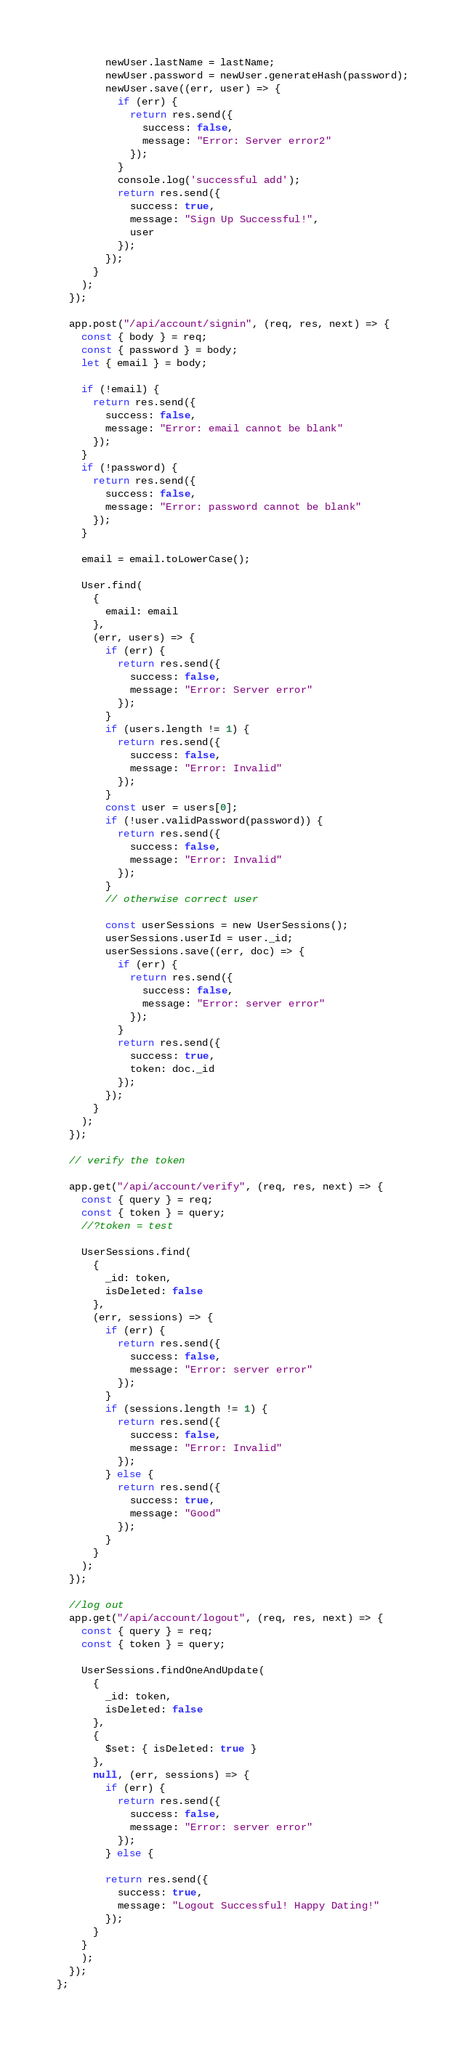<code> <loc_0><loc_0><loc_500><loc_500><_JavaScript_>        newUser.lastName = lastName;
        newUser.password = newUser.generateHash(password);
        newUser.save((err, user) => {
          if (err) {
            return res.send({
              success: false,
              message: "Error: Server error2"
            });
          }
          console.log('successful add');
          return res.send({
            success: true,
            message: "Sign Up Successful!",
            user
          });
        });
      }
    );
  });

  app.post("/api/account/signin", (req, res, next) => {
    const { body } = req;
    const { password } = body;
    let { email } = body;

    if (!email) {
      return res.send({
        success: false,
        message: "Error: email cannot be blank"
      });
    }
    if (!password) {
      return res.send({
        success: false,
        message: "Error: password cannot be blank"
      });
    }

    email = email.toLowerCase();

    User.find(
      {
        email: email
      },
      (err, users) => {
        if (err) {
          return res.send({
            success: false,
            message: "Error: Server error"
          });
        }
        if (users.length != 1) {
          return res.send({
            success: false,
            message: "Error: Invalid"
          });
        }
        const user = users[0];
        if (!user.validPassword(password)) {
          return res.send({
            success: false,
            message: "Error: Invalid"
          });
        }
        // otherwise correct user

        const userSessions = new UserSessions();
        userSessions.userId = user._id;
        userSessions.save((err, doc) => {
          if (err) {
            return res.send({
              success: false,
              message: "Error: server error"
            });
          }
          return res.send({
            success: true,
            token: doc._id
          });
        });
      }
    );
  });

  // verify the token

  app.get("/api/account/verify", (req, res, next) => {
    const { query } = req;
    const { token } = query;
    //?token = test

    UserSessions.find(
      {
        _id: token,
        isDeleted: false
      },
      (err, sessions) => {
        if (err) {
          return res.send({
            success: false,
            message: "Error: server error"
          });
        }
        if (sessions.length != 1) {
          return res.send({
            success: false,
            message: "Error: Invalid"
          });
        } else {
          return res.send({
            success: true,
            message: "Good"
          });
        }
      }
    );
  });

  //log out
  app.get("/api/account/logout", (req, res, next) => {
    const { query } = req;
    const { token } = query;

    UserSessions.findOneAndUpdate(
      {
        _id: token,
        isDeleted: false
      },
      {
        $set: { isDeleted: true }
      },
      null, (err, sessions) => {
        if (err) {
          return res.send({
            success: false,
            message: "Error: server error"
          });
        } else {
        
        return res.send({
          success: true,
          message: "Logout Successful! Happy Dating!"
        });
      }
    }
    );
  });
};
</code> 